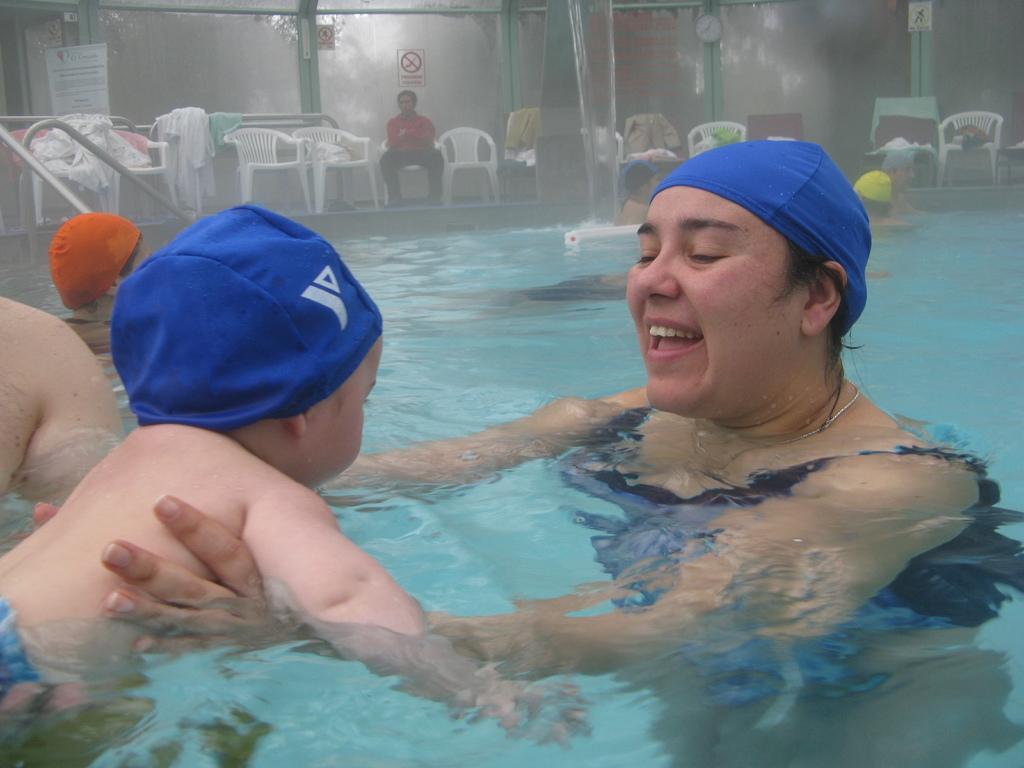How would you summarize this image in a sentence or two? In this picture, we see people are swimming in the water. In the background, we see a man in red T-shirt is sitting on the chair. Beside him, we see empty chairs. Behind him, we see a glass wall from which we can see trees. This picture is clicked in the swimming pool. 